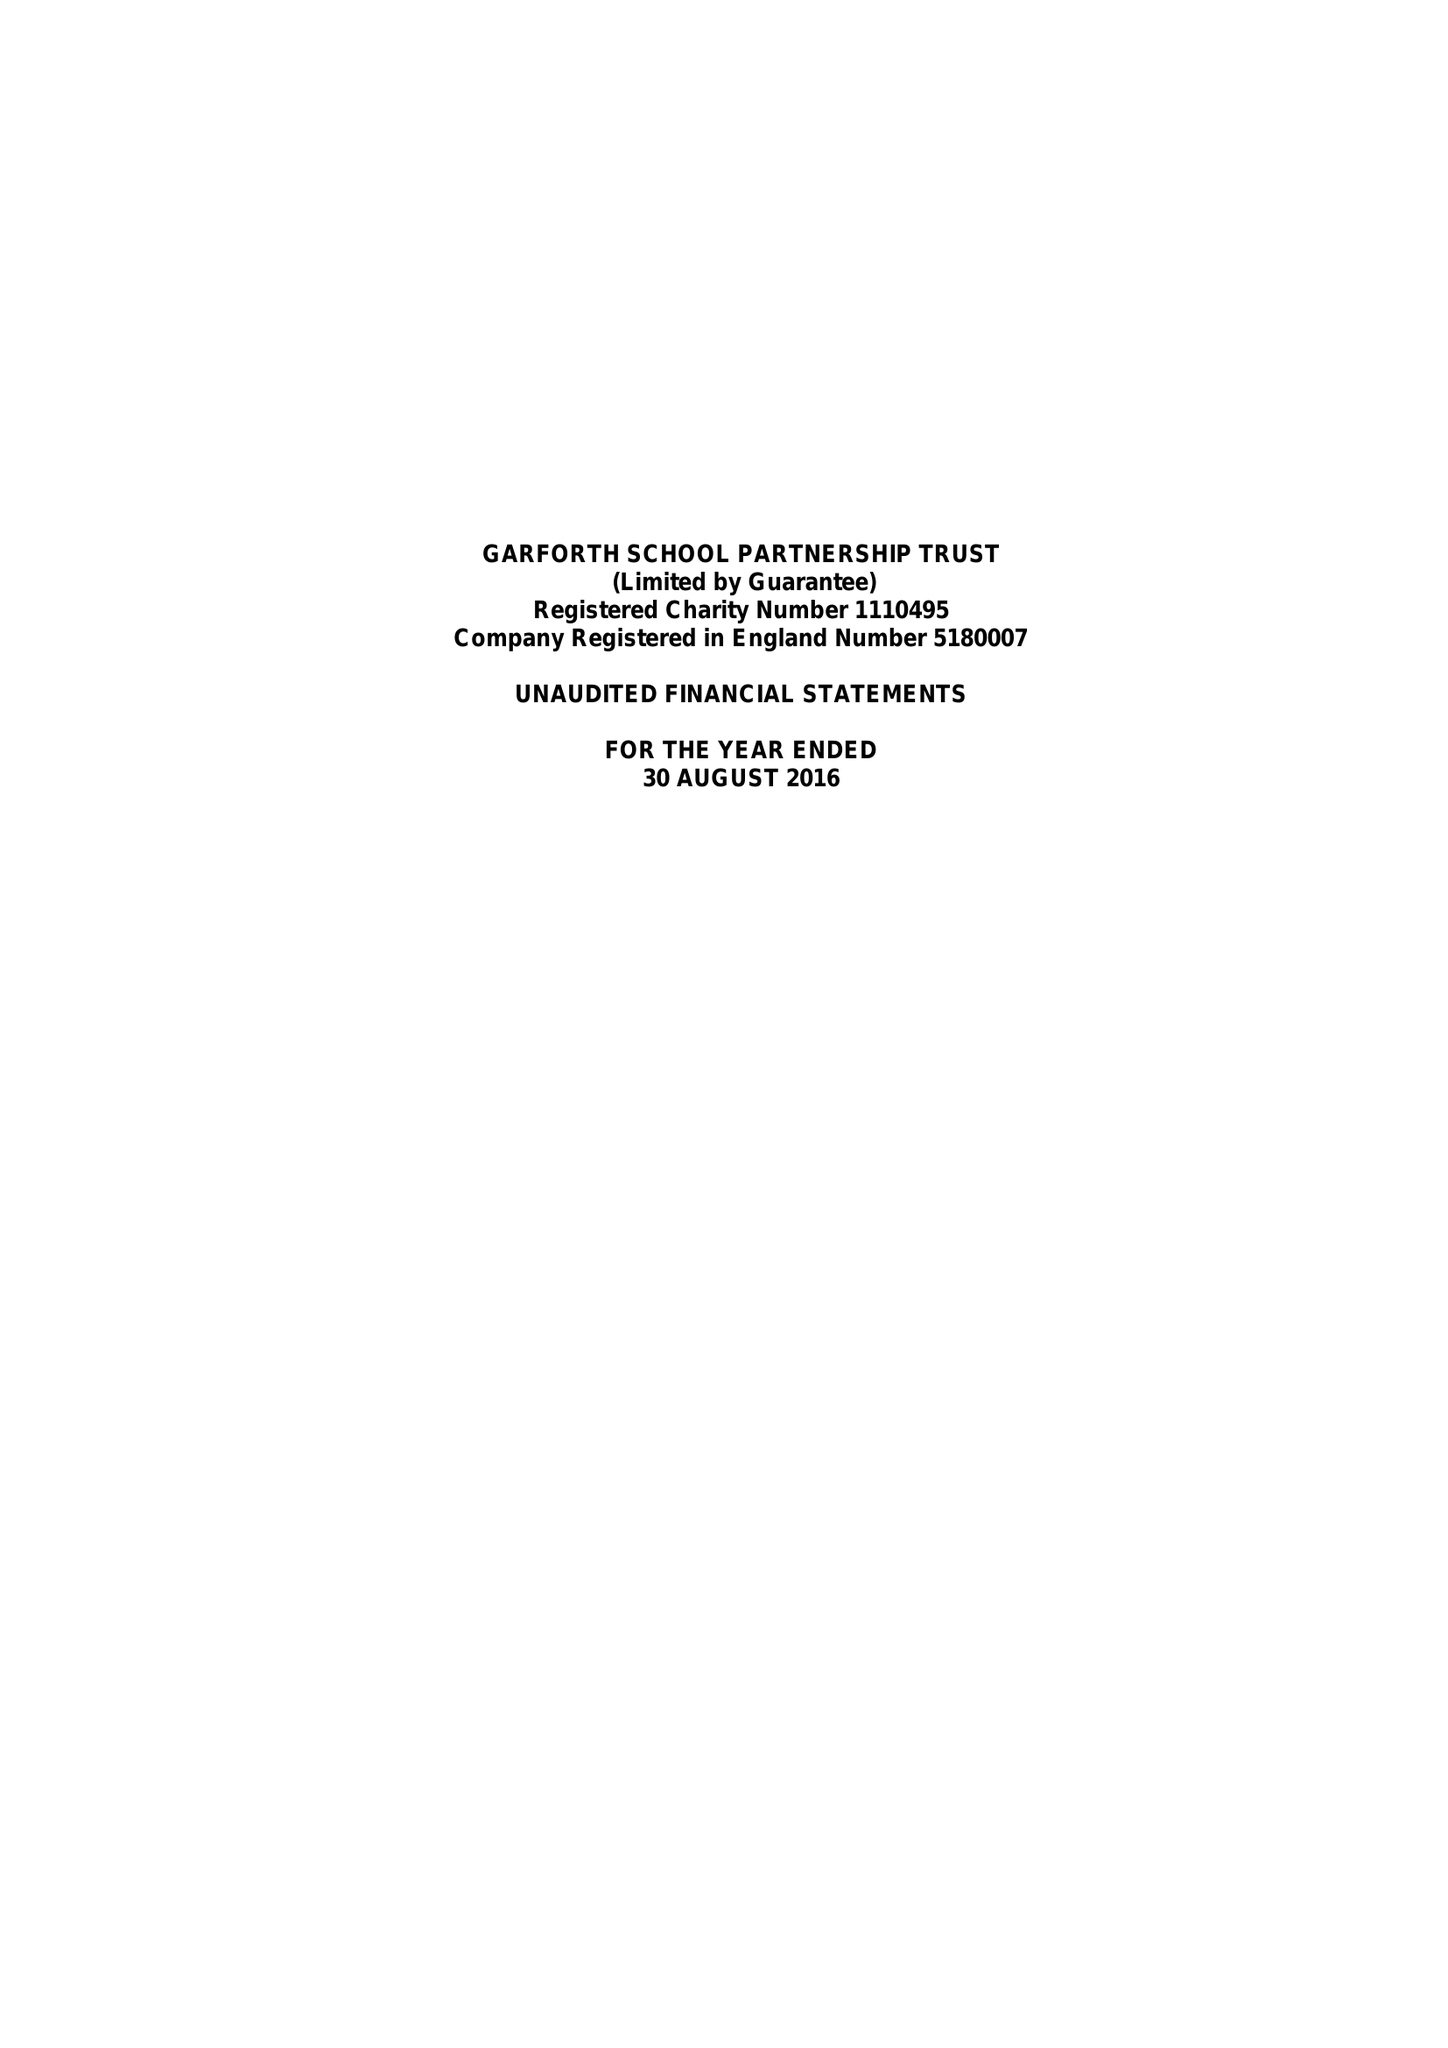What is the value for the address__postcode?
Answer the question using a single word or phrase. LS25 1LL 